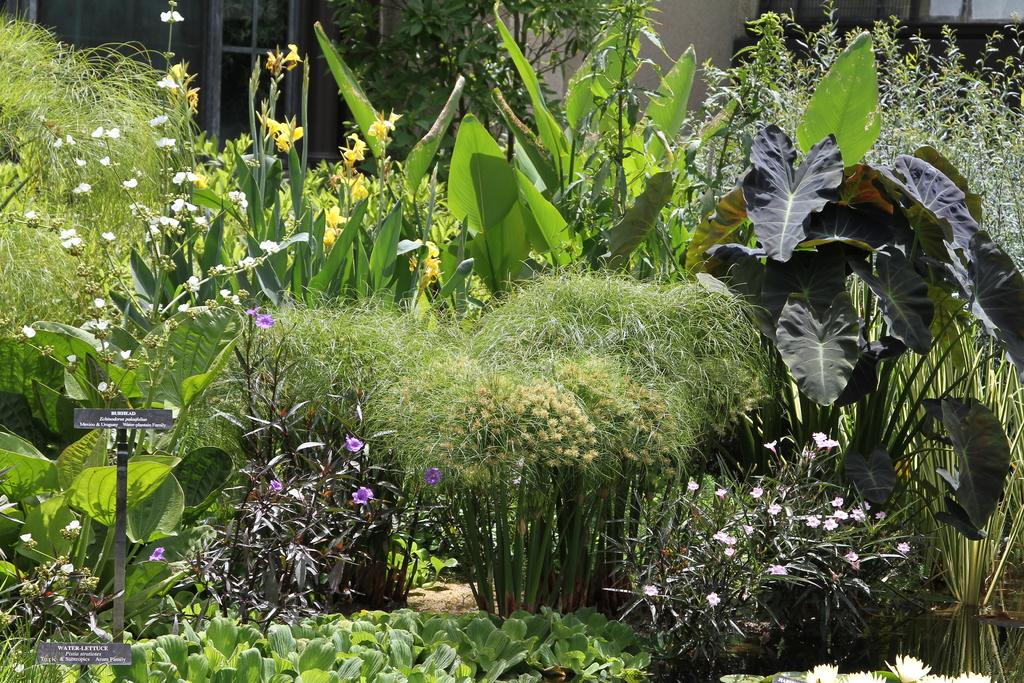What type of natural vegetation is visible in the image? There are trees in the image. What other type of plant life can be seen in the image? There are plants in the image. What can be seen in the background of the image? There is a building in the background of the image. What type of tools does the carpenter use in the image? There is no carpenter present in the image. What type of furniture does the fireman use in the image? There is no fireman or furniture present in the image. 